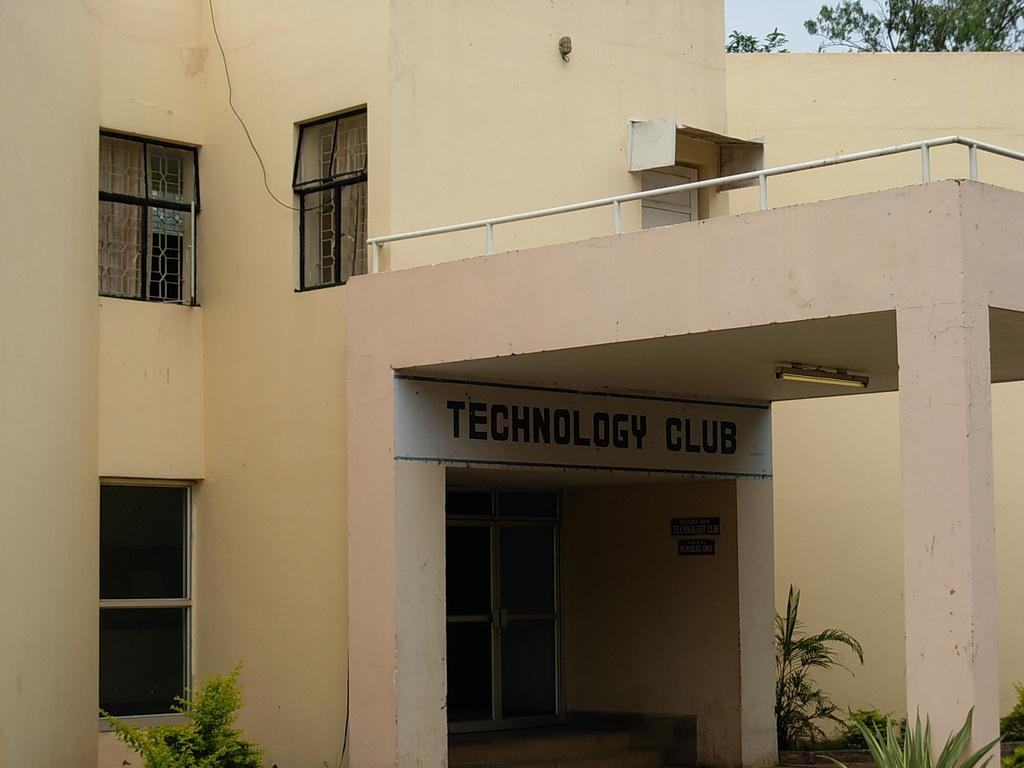Could you give a brief overview of what you see in this image? In this image I can see the building in cream color and I can also see few glass windows and the trees are in green color. Background the sky is in white color. 